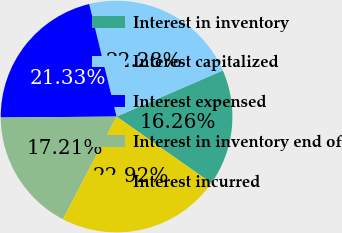Convert chart to OTSL. <chart><loc_0><loc_0><loc_500><loc_500><pie_chart><fcel>Interest in inventory<fcel>Interest capitalized<fcel>Interest expensed<fcel>Interest in inventory end of<fcel>Interest incurred<nl><fcel>16.26%<fcel>22.28%<fcel>21.33%<fcel>17.21%<fcel>22.92%<nl></chart> 